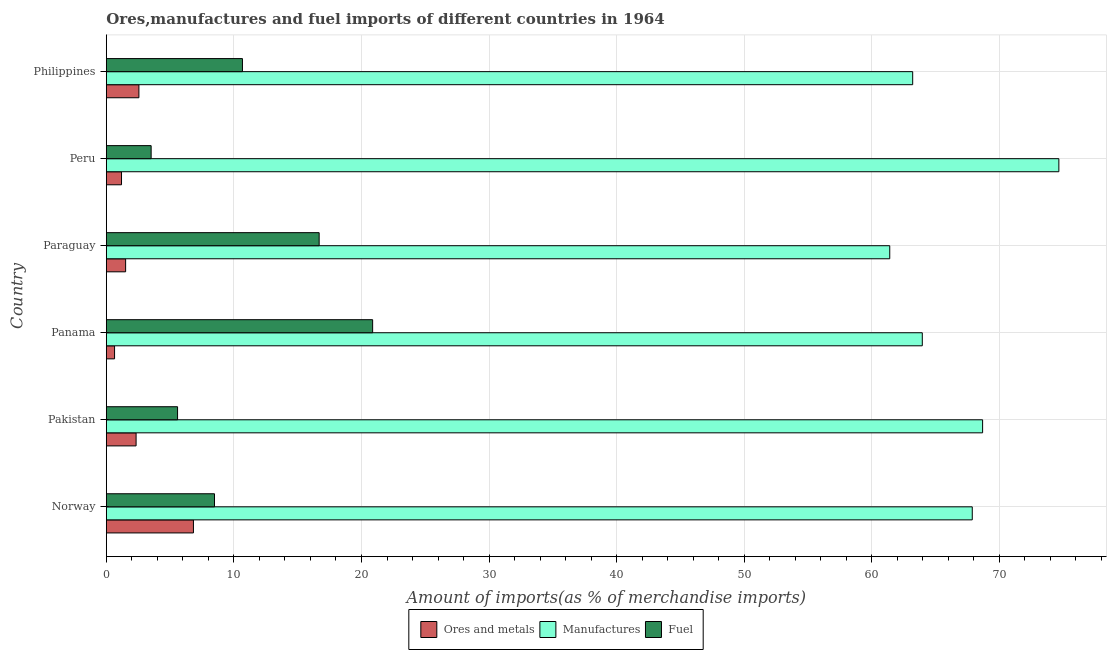How many different coloured bars are there?
Offer a terse response. 3. How many groups of bars are there?
Give a very brief answer. 6. Are the number of bars per tick equal to the number of legend labels?
Offer a terse response. Yes. What is the label of the 2nd group of bars from the top?
Offer a terse response. Peru. In how many cases, is the number of bars for a given country not equal to the number of legend labels?
Keep it short and to the point. 0. What is the percentage of ores and metals imports in Panama?
Your answer should be compact. 0.65. Across all countries, what is the maximum percentage of fuel imports?
Your response must be concise. 20.87. Across all countries, what is the minimum percentage of fuel imports?
Provide a short and direct response. 3.51. In which country was the percentage of manufactures imports minimum?
Ensure brevity in your answer.  Paraguay. What is the total percentage of ores and metals imports in the graph?
Provide a short and direct response. 15.06. What is the difference between the percentage of manufactures imports in Norway and that in Pakistan?
Offer a very short reply. -0.81. What is the difference between the percentage of manufactures imports in Paraguay and the percentage of ores and metals imports in Peru?
Keep it short and to the point. 60.21. What is the average percentage of ores and metals imports per country?
Your answer should be very brief. 2.51. What is the difference between the percentage of fuel imports and percentage of manufactures imports in Peru?
Provide a succinct answer. -71.15. What is the ratio of the percentage of manufactures imports in Norway to that in Philippines?
Give a very brief answer. 1.07. Is the percentage of manufactures imports in Panama less than that in Peru?
Provide a succinct answer. Yes. Is the difference between the percentage of ores and metals imports in Paraguay and Peru greater than the difference between the percentage of manufactures imports in Paraguay and Peru?
Provide a succinct answer. Yes. What is the difference between the highest and the second highest percentage of manufactures imports?
Ensure brevity in your answer.  5.98. What is the difference between the highest and the lowest percentage of fuel imports?
Provide a succinct answer. 17.36. Is the sum of the percentage of manufactures imports in Norway and Peru greater than the maximum percentage of fuel imports across all countries?
Offer a very short reply. Yes. What does the 3rd bar from the top in Philippines represents?
Your answer should be compact. Ores and metals. What does the 3rd bar from the bottom in Philippines represents?
Keep it short and to the point. Fuel. How many bars are there?
Your answer should be compact. 18. Are all the bars in the graph horizontal?
Provide a short and direct response. Yes. What is the difference between two consecutive major ticks on the X-axis?
Keep it short and to the point. 10. Are the values on the major ticks of X-axis written in scientific E-notation?
Provide a succinct answer. No. Does the graph contain grids?
Make the answer very short. Yes. Where does the legend appear in the graph?
Give a very brief answer. Bottom center. How are the legend labels stacked?
Provide a succinct answer. Horizontal. What is the title of the graph?
Keep it short and to the point. Ores,manufactures and fuel imports of different countries in 1964. What is the label or title of the X-axis?
Ensure brevity in your answer.  Amount of imports(as % of merchandise imports). What is the Amount of imports(as % of merchandise imports) of Ores and metals in Norway?
Ensure brevity in your answer.  6.83. What is the Amount of imports(as % of merchandise imports) of Manufactures in Norway?
Offer a very short reply. 67.87. What is the Amount of imports(as % of merchandise imports) in Fuel in Norway?
Offer a very short reply. 8.48. What is the Amount of imports(as % of merchandise imports) in Ores and metals in Pakistan?
Keep it short and to the point. 2.33. What is the Amount of imports(as % of merchandise imports) of Manufactures in Pakistan?
Provide a succinct answer. 68.68. What is the Amount of imports(as % of merchandise imports) in Fuel in Pakistan?
Your response must be concise. 5.58. What is the Amount of imports(as % of merchandise imports) in Ores and metals in Panama?
Your answer should be very brief. 0.65. What is the Amount of imports(as % of merchandise imports) of Manufactures in Panama?
Your response must be concise. 63.96. What is the Amount of imports(as % of merchandise imports) in Fuel in Panama?
Your answer should be very brief. 20.87. What is the Amount of imports(as % of merchandise imports) in Ores and metals in Paraguay?
Your answer should be compact. 1.51. What is the Amount of imports(as % of merchandise imports) of Manufactures in Paraguay?
Your answer should be very brief. 61.4. What is the Amount of imports(as % of merchandise imports) of Fuel in Paraguay?
Provide a succinct answer. 16.68. What is the Amount of imports(as % of merchandise imports) in Ores and metals in Peru?
Give a very brief answer. 1.19. What is the Amount of imports(as % of merchandise imports) of Manufactures in Peru?
Ensure brevity in your answer.  74.66. What is the Amount of imports(as % of merchandise imports) in Fuel in Peru?
Keep it short and to the point. 3.51. What is the Amount of imports(as % of merchandise imports) of Ores and metals in Philippines?
Ensure brevity in your answer.  2.55. What is the Amount of imports(as % of merchandise imports) in Manufactures in Philippines?
Your answer should be compact. 63.2. What is the Amount of imports(as % of merchandise imports) in Fuel in Philippines?
Keep it short and to the point. 10.67. Across all countries, what is the maximum Amount of imports(as % of merchandise imports) in Ores and metals?
Your answer should be compact. 6.83. Across all countries, what is the maximum Amount of imports(as % of merchandise imports) of Manufactures?
Provide a short and direct response. 74.66. Across all countries, what is the maximum Amount of imports(as % of merchandise imports) in Fuel?
Provide a short and direct response. 20.87. Across all countries, what is the minimum Amount of imports(as % of merchandise imports) in Ores and metals?
Your answer should be very brief. 0.65. Across all countries, what is the minimum Amount of imports(as % of merchandise imports) of Manufactures?
Keep it short and to the point. 61.4. Across all countries, what is the minimum Amount of imports(as % of merchandise imports) in Fuel?
Provide a succinct answer. 3.51. What is the total Amount of imports(as % of merchandise imports) in Ores and metals in the graph?
Give a very brief answer. 15.06. What is the total Amount of imports(as % of merchandise imports) in Manufactures in the graph?
Ensure brevity in your answer.  399.78. What is the total Amount of imports(as % of merchandise imports) of Fuel in the graph?
Keep it short and to the point. 65.8. What is the difference between the Amount of imports(as % of merchandise imports) of Ores and metals in Norway and that in Pakistan?
Your response must be concise. 4.5. What is the difference between the Amount of imports(as % of merchandise imports) in Manufactures in Norway and that in Pakistan?
Give a very brief answer. -0.81. What is the difference between the Amount of imports(as % of merchandise imports) in Fuel in Norway and that in Pakistan?
Your answer should be compact. 2.89. What is the difference between the Amount of imports(as % of merchandise imports) in Ores and metals in Norway and that in Panama?
Your answer should be very brief. 6.18. What is the difference between the Amount of imports(as % of merchandise imports) of Manufactures in Norway and that in Panama?
Your answer should be very brief. 3.92. What is the difference between the Amount of imports(as % of merchandise imports) of Fuel in Norway and that in Panama?
Provide a succinct answer. -12.4. What is the difference between the Amount of imports(as % of merchandise imports) of Ores and metals in Norway and that in Paraguay?
Provide a short and direct response. 5.32. What is the difference between the Amount of imports(as % of merchandise imports) of Manufactures in Norway and that in Paraguay?
Make the answer very short. 6.47. What is the difference between the Amount of imports(as % of merchandise imports) of Fuel in Norway and that in Paraguay?
Keep it short and to the point. -8.2. What is the difference between the Amount of imports(as % of merchandise imports) in Ores and metals in Norway and that in Peru?
Provide a short and direct response. 5.64. What is the difference between the Amount of imports(as % of merchandise imports) in Manufactures in Norway and that in Peru?
Give a very brief answer. -6.79. What is the difference between the Amount of imports(as % of merchandise imports) in Fuel in Norway and that in Peru?
Provide a succinct answer. 4.97. What is the difference between the Amount of imports(as % of merchandise imports) of Ores and metals in Norway and that in Philippines?
Provide a short and direct response. 4.27. What is the difference between the Amount of imports(as % of merchandise imports) in Manufactures in Norway and that in Philippines?
Make the answer very short. 4.67. What is the difference between the Amount of imports(as % of merchandise imports) in Fuel in Norway and that in Philippines?
Keep it short and to the point. -2.19. What is the difference between the Amount of imports(as % of merchandise imports) in Ores and metals in Pakistan and that in Panama?
Your answer should be compact. 1.69. What is the difference between the Amount of imports(as % of merchandise imports) in Manufactures in Pakistan and that in Panama?
Make the answer very short. 4.73. What is the difference between the Amount of imports(as % of merchandise imports) in Fuel in Pakistan and that in Panama?
Keep it short and to the point. -15.29. What is the difference between the Amount of imports(as % of merchandise imports) of Ores and metals in Pakistan and that in Paraguay?
Offer a very short reply. 0.82. What is the difference between the Amount of imports(as % of merchandise imports) of Manufactures in Pakistan and that in Paraguay?
Your response must be concise. 7.28. What is the difference between the Amount of imports(as % of merchandise imports) of Fuel in Pakistan and that in Paraguay?
Offer a terse response. -11.1. What is the difference between the Amount of imports(as % of merchandise imports) of Ores and metals in Pakistan and that in Peru?
Give a very brief answer. 1.14. What is the difference between the Amount of imports(as % of merchandise imports) of Manufactures in Pakistan and that in Peru?
Your answer should be very brief. -5.98. What is the difference between the Amount of imports(as % of merchandise imports) in Fuel in Pakistan and that in Peru?
Ensure brevity in your answer.  2.07. What is the difference between the Amount of imports(as % of merchandise imports) in Ores and metals in Pakistan and that in Philippines?
Offer a very short reply. -0.22. What is the difference between the Amount of imports(as % of merchandise imports) of Manufactures in Pakistan and that in Philippines?
Offer a very short reply. 5.48. What is the difference between the Amount of imports(as % of merchandise imports) of Fuel in Pakistan and that in Philippines?
Offer a terse response. -5.09. What is the difference between the Amount of imports(as % of merchandise imports) in Ores and metals in Panama and that in Paraguay?
Offer a very short reply. -0.87. What is the difference between the Amount of imports(as % of merchandise imports) in Manufactures in Panama and that in Paraguay?
Offer a very short reply. 2.55. What is the difference between the Amount of imports(as % of merchandise imports) of Fuel in Panama and that in Paraguay?
Give a very brief answer. 4.19. What is the difference between the Amount of imports(as % of merchandise imports) in Ores and metals in Panama and that in Peru?
Your response must be concise. -0.55. What is the difference between the Amount of imports(as % of merchandise imports) of Manufactures in Panama and that in Peru?
Your answer should be very brief. -10.7. What is the difference between the Amount of imports(as % of merchandise imports) in Fuel in Panama and that in Peru?
Give a very brief answer. 17.36. What is the difference between the Amount of imports(as % of merchandise imports) in Ores and metals in Panama and that in Philippines?
Provide a succinct answer. -1.91. What is the difference between the Amount of imports(as % of merchandise imports) in Manufactures in Panama and that in Philippines?
Ensure brevity in your answer.  0.75. What is the difference between the Amount of imports(as % of merchandise imports) in Fuel in Panama and that in Philippines?
Ensure brevity in your answer.  10.2. What is the difference between the Amount of imports(as % of merchandise imports) of Ores and metals in Paraguay and that in Peru?
Provide a short and direct response. 0.32. What is the difference between the Amount of imports(as % of merchandise imports) of Manufactures in Paraguay and that in Peru?
Offer a terse response. -13.26. What is the difference between the Amount of imports(as % of merchandise imports) of Fuel in Paraguay and that in Peru?
Make the answer very short. 13.17. What is the difference between the Amount of imports(as % of merchandise imports) of Ores and metals in Paraguay and that in Philippines?
Give a very brief answer. -1.04. What is the difference between the Amount of imports(as % of merchandise imports) of Manufactures in Paraguay and that in Philippines?
Your answer should be very brief. -1.8. What is the difference between the Amount of imports(as % of merchandise imports) in Fuel in Paraguay and that in Philippines?
Your answer should be compact. 6.01. What is the difference between the Amount of imports(as % of merchandise imports) in Ores and metals in Peru and that in Philippines?
Make the answer very short. -1.36. What is the difference between the Amount of imports(as % of merchandise imports) of Manufactures in Peru and that in Philippines?
Give a very brief answer. 11.46. What is the difference between the Amount of imports(as % of merchandise imports) in Fuel in Peru and that in Philippines?
Give a very brief answer. -7.16. What is the difference between the Amount of imports(as % of merchandise imports) in Ores and metals in Norway and the Amount of imports(as % of merchandise imports) in Manufactures in Pakistan?
Keep it short and to the point. -61.86. What is the difference between the Amount of imports(as % of merchandise imports) in Ores and metals in Norway and the Amount of imports(as % of merchandise imports) in Fuel in Pakistan?
Offer a terse response. 1.24. What is the difference between the Amount of imports(as % of merchandise imports) of Manufactures in Norway and the Amount of imports(as % of merchandise imports) of Fuel in Pakistan?
Offer a terse response. 62.29. What is the difference between the Amount of imports(as % of merchandise imports) of Ores and metals in Norway and the Amount of imports(as % of merchandise imports) of Manufactures in Panama?
Provide a succinct answer. -57.13. What is the difference between the Amount of imports(as % of merchandise imports) of Ores and metals in Norway and the Amount of imports(as % of merchandise imports) of Fuel in Panama?
Give a very brief answer. -14.05. What is the difference between the Amount of imports(as % of merchandise imports) of Manufactures in Norway and the Amount of imports(as % of merchandise imports) of Fuel in Panama?
Make the answer very short. 47. What is the difference between the Amount of imports(as % of merchandise imports) in Ores and metals in Norway and the Amount of imports(as % of merchandise imports) in Manufactures in Paraguay?
Keep it short and to the point. -54.58. What is the difference between the Amount of imports(as % of merchandise imports) in Ores and metals in Norway and the Amount of imports(as % of merchandise imports) in Fuel in Paraguay?
Keep it short and to the point. -9.85. What is the difference between the Amount of imports(as % of merchandise imports) of Manufactures in Norway and the Amount of imports(as % of merchandise imports) of Fuel in Paraguay?
Offer a very short reply. 51.19. What is the difference between the Amount of imports(as % of merchandise imports) of Ores and metals in Norway and the Amount of imports(as % of merchandise imports) of Manufactures in Peru?
Provide a short and direct response. -67.83. What is the difference between the Amount of imports(as % of merchandise imports) of Ores and metals in Norway and the Amount of imports(as % of merchandise imports) of Fuel in Peru?
Offer a terse response. 3.32. What is the difference between the Amount of imports(as % of merchandise imports) of Manufactures in Norway and the Amount of imports(as % of merchandise imports) of Fuel in Peru?
Your answer should be very brief. 64.36. What is the difference between the Amount of imports(as % of merchandise imports) in Ores and metals in Norway and the Amount of imports(as % of merchandise imports) in Manufactures in Philippines?
Your answer should be very brief. -56.37. What is the difference between the Amount of imports(as % of merchandise imports) of Ores and metals in Norway and the Amount of imports(as % of merchandise imports) of Fuel in Philippines?
Your response must be concise. -3.84. What is the difference between the Amount of imports(as % of merchandise imports) in Manufactures in Norway and the Amount of imports(as % of merchandise imports) in Fuel in Philippines?
Offer a terse response. 57.2. What is the difference between the Amount of imports(as % of merchandise imports) of Ores and metals in Pakistan and the Amount of imports(as % of merchandise imports) of Manufactures in Panama?
Offer a terse response. -61.62. What is the difference between the Amount of imports(as % of merchandise imports) in Ores and metals in Pakistan and the Amount of imports(as % of merchandise imports) in Fuel in Panama?
Ensure brevity in your answer.  -18.54. What is the difference between the Amount of imports(as % of merchandise imports) in Manufactures in Pakistan and the Amount of imports(as % of merchandise imports) in Fuel in Panama?
Your response must be concise. 47.81. What is the difference between the Amount of imports(as % of merchandise imports) of Ores and metals in Pakistan and the Amount of imports(as % of merchandise imports) of Manufactures in Paraguay?
Make the answer very short. -59.07. What is the difference between the Amount of imports(as % of merchandise imports) in Ores and metals in Pakistan and the Amount of imports(as % of merchandise imports) in Fuel in Paraguay?
Make the answer very short. -14.35. What is the difference between the Amount of imports(as % of merchandise imports) in Manufactures in Pakistan and the Amount of imports(as % of merchandise imports) in Fuel in Paraguay?
Provide a short and direct response. 52. What is the difference between the Amount of imports(as % of merchandise imports) of Ores and metals in Pakistan and the Amount of imports(as % of merchandise imports) of Manufactures in Peru?
Offer a very short reply. -72.33. What is the difference between the Amount of imports(as % of merchandise imports) in Ores and metals in Pakistan and the Amount of imports(as % of merchandise imports) in Fuel in Peru?
Your answer should be compact. -1.18. What is the difference between the Amount of imports(as % of merchandise imports) in Manufactures in Pakistan and the Amount of imports(as % of merchandise imports) in Fuel in Peru?
Your answer should be very brief. 65.17. What is the difference between the Amount of imports(as % of merchandise imports) of Ores and metals in Pakistan and the Amount of imports(as % of merchandise imports) of Manufactures in Philippines?
Your answer should be compact. -60.87. What is the difference between the Amount of imports(as % of merchandise imports) of Ores and metals in Pakistan and the Amount of imports(as % of merchandise imports) of Fuel in Philippines?
Give a very brief answer. -8.34. What is the difference between the Amount of imports(as % of merchandise imports) of Manufactures in Pakistan and the Amount of imports(as % of merchandise imports) of Fuel in Philippines?
Your answer should be compact. 58.01. What is the difference between the Amount of imports(as % of merchandise imports) in Ores and metals in Panama and the Amount of imports(as % of merchandise imports) in Manufactures in Paraguay?
Provide a succinct answer. -60.76. What is the difference between the Amount of imports(as % of merchandise imports) in Ores and metals in Panama and the Amount of imports(as % of merchandise imports) in Fuel in Paraguay?
Provide a succinct answer. -16.04. What is the difference between the Amount of imports(as % of merchandise imports) of Manufactures in Panama and the Amount of imports(as % of merchandise imports) of Fuel in Paraguay?
Your response must be concise. 47.27. What is the difference between the Amount of imports(as % of merchandise imports) in Ores and metals in Panama and the Amount of imports(as % of merchandise imports) in Manufactures in Peru?
Offer a very short reply. -74.01. What is the difference between the Amount of imports(as % of merchandise imports) in Ores and metals in Panama and the Amount of imports(as % of merchandise imports) in Fuel in Peru?
Keep it short and to the point. -2.87. What is the difference between the Amount of imports(as % of merchandise imports) of Manufactures in Panama and the Amount of imports(as % of merchandise imports) of Fuel in Peru?
Keep it short and to the point. 60.44. What is the difference between the Amount of imports(as % of merchandise imports) in Ores and metals in Panama and the Amount of imports(as % of merchandise imports) in Manufactures in Philippines?
Offer a terse response. -62.56. What is the difference between the Amount of imports(as % of merchandise imports) in Ores and metals in Panama and the Amount of imports(as % of merchandise imports) in Fuel in Philippines?
Provide a short and direct response. -10.02. What is the difference between the Amount of imports(as % of merchandise imports) in Manufactures in Panama and the Amount of imports(as % of merchandise imports) in Fuel in Philippines?
Offer a very short reply. 53.29. What is the difference between the Amount of imports(as % of merchandise imports) in Ores and metals in Paraguay and the Amount of imports(as % of merchandise imports) in Manufactures in Peru?
Give a very brief answer. -73.15. What is the difference between the Amount of imports(as % of merchandise imports) of Ores and metals in Paraguay and the Amount of imports(as % of merchandise imports) of Fuel in Peru?
Your response must be concise. -2. What is the difference between the Amount of imports(as % of merchandise imports) of Manufactures in Paraguay and the Amount of imports(as % of merchandise imports) of Fuel in Peru?
Your answer should be very brief. 57.89. What is the difference between the Amount of imports(as % of merchandise imports) of Ores and metals in Paraguay and the Amount of imports(as % of merchandise imports) of Manufactures in Philippines?
Give a very brief answer. -61.69. What is the difference between the Amount of imports(as % of merchandise imports) in Ores and metals in Paraguay and the Amount of imports(as % of merchandise imports) in Fuel in Philippines?
Give a very brief answer. -9.16. What is the difference between the Amount of imports(as % of merchandise imports) of Manufactures in Paraguay and the Amount of imports(as % of merchandise imports) of Fuel in Philippines?
Your response must be concise. 50.74. What is the difference between the Amount of imports(as % of merchandise imports) in Ores and metals in Peru and the Amount of imports(as % of merchandise imports) in Manufactures in Philippines?
Ensure brevity in your answer.  -62.01. What is the difference between the Amount of imports(as % of merchandise imports) of Ores and metals in Peru and the Amount of imports(as % of merchandise imports) of Fuel in Philippines?
Give a very brief answer. -9.48. What is the difference between the Amount of imports(as % of merchandise imports) of Manufactures in Peru and the Amount of imports(as % of merchandise imports) of Fuel in Philippines?
Offer a terse response. 63.99. What is the average Amount of imports(as % of merchandise imports) of Ores and metals per country?
Your answer should be compact. 2.51. What is the average Amount of imports(as % of merchandise imports) in Manufactures per country?
Your answer should be compact. 66.63. What is the average Amount of imports(as % of merchandise imports) of Fuel per country?
Provide a short and direct response. 10.97. What is the difference between the Amount of imports(as % of merchandise imports) of Ores and metals and Amount of imports(as % of merchandise imports) of Manufactures in Norway?
Your answer should be compact. -61.04. What is the difference between the Amount of imports(as % of merchandise imports) in Ores and metals and Amount of imports(as % of merchandise imports) in Fuel in Norway?
Ensure brevity in your answer.  -1.65. What is the difference between the Amount of imports(as % of merchandise imports) in Manufactures and Amount of imports(as % of merchandise imports) in Fuel in Norway?
Your response must be concise. 59.39. What is the difference between the Amount of imports(as % of merchandise imports) in Ores and metals and Amount of imports(as % of merchandise imports) in Manufactures in Pakistan?
Ensure brevity in your answer.  -66.35. What is the difference between the Amount of imports(as % of merchandise imports) of Ores and metals and Amount of imports(as % of merchandise imports) of Fuel in Pakistan?
Offer a terse response. -3.25. What is the difference between the Amount of imports(as % of merchandise imports) of Manufactures and Amount of imports(as % of merchandise imports) of Fuel in Pakistan?
Your response must be concise. 63.1. What is the difference between the Amount of imports(as % of merchandise imports) of Ores and metals and Amount of imports(as % of merchandise imports) of Manufactures in Panama?
Give a very brief answer. -63.31. What is the difference between the Amount of imports(as % of merchandise imports) of Ores and metals and Amount of imports(as % of merchandise imports) of Fuel in Panama?
Offer a terse response. -20.23. What is the difference between the Amount of imports(as % of merchandise imports) of Manufactures and Amount of imports(as % of merchandise imports) of Fuel in Panama?
Your answer should be compact. 43.08. What is the difference between the Amount of imports(as % of merchandise imports) of Ores and metals and Amount of imports(as % of merchandise imports) of Manufactures in Paraguay?
Your answer should be very brief. -59.89. What is the difference between the Amount of imports(as % of merchandise imports) of Ores and metals and Amount of imports(as % of merchandise imports) of Fuel in Paraguay?
Make the answer very short. -15.17. What is the difference between the Amount of imports(as % of merchandise imports) in Manufactures and Amount of imports(as % of merchandise imports) in Fuel in Paraguay?
Your answer should be compact. 44.72. What is the difference between the Amount of imports(as % of merchandise imports) in Ores and metals and Amount of imports(as % of merchandise imports) in Manufactures in Peru?
Offer a very short reply. -73.47. What is the difference between the Amount of imports(as % of merchandise imports) in Ores and metals and Amount of imports(as % of merchandise imports) in Fuel in Peru?
Keep it short and to the point. -2.32. What is the difference between the Amount of imports(as % of merchandise imports) in Manufactures and Amount of imports(as % of merchandise imports) in Fuel in Peru?
Offer a terse response. 71.15. What is the difference between the Amount of imports(as % of merchandise imports) in Ores and metals and Amount of imports(as % of merchandise imports) in Manufactures in Philippines?
Provide a succinct answer. -60.65. What is the difference between the Amount of imports(as % of merchandise imports) in Ores and metals and Amount of imports(as % of merchandise imports) in Fuel in Philippines?
Your response must be concise. -8.12. What is the difference between the Amount of imports(as % of merchandise imports) of Manufactures and Amount of imports(as % of merchandise imports) of Fuel in Philippines?
Make the answer very short. 52.53. What is the ratio of the Amount of imports(as % of merchandise imports) in Ores and metals in Norway to that in Pakistan?
Provide a succinct answer. 2.93. What is the ratio of the Amount of imports(as % of merchandise imports) in Fuel in Norway to that in Pakistan?
Provide a short and direct response. 1.52. What is the ratio of the Amount of imports(as % of merchandise imports) in Ores and metals in Norway to that in Panama?
Ensure brevity in your answer.  10.58. What is the ratio of the Amount of imports(as % of merchandise imports) in Manufactures in Norway to that in Panama?
Ensure brevity in your answer.  1.06. What is the ratio of the Amount of imports(as % of merchandise imports) of Fuel in Norway to that in Panama?
Ensure brevity in your answer.  0.41. What is the ratio of the Amount of imports(as % of merchandise imports) in Ores and metals in Norway to that in Paraguay?
Give a very brief answer. 4.51. What is the ratio of the Amount of imports(as % of merchandise imports) in Manufactures in Norway to that in Paraguay?
Keep it short and to the point. 1.11. What is the ratio of the Amount of imports(as % of merchandise imports) in Fuel in Norway to that in Paraguay?
Your answer should be very brief. 0.51. What is the ratio of the Amount of imports(as % of merchandise imports) in Ores and metals in Norway to that in Peru?
Make the answer very short. 5.74. What is the ratio of the Amount of imports(as % of merchandise imports) in Fuel in Norway to that in Peru?
Ensure brevity in your answer.  2.41. What is the ratio of the Amount of imports(as % of merchandise imports) in Ores and metals in Norway to that in Philippines?
Your answer should be very brief. 2.67. What is the ratio of the Amount of imports(as % of merchandise imports) in Manufactures in Norway to that in Philippines?
Make the answer very short. 1.07. What is the ratio of the Amount of imports(as % of merchandise imports) of Fuel in Norway to that in Philippines?
Make the answer very short. 0.79. What is the ratio of the Amount of imports(as % of merchandise imports) in Ores and metals in Pakistan to that in Panama?
Your response must be concise. 3.62. What is the ratio of the Amount of imports(as % of merchandise imports) of Manufactures in Pakistan to that in Panama?
Your response must be concise. 1.07. What is the ratio of the Amount of imports(as % of merchandise imports) of Fuel in Pakistan to that in Panama?
Your answer should be very brief. 0.27. What is the ratio of the Amount of imports(as % of merchandise imports) of Ores and metals in Pakistan to that in Paraguay?
Offer a terse response. 1.54. What is the ratio of the Amount of imports(as % of merchandise imports) of Manufactures in Pakistan to that in Paraguay?
Offer a very short reply. 1.12. What is the ratio of the Amount of imports(as % of merchandise imports) in Fuel in Pakistan to that in Paraguay?
Your answer should be very brief. 0.33. What is the ratio of the Amount of imports(as % of merchandise imports) of Ores and metals in Pakistan to that in Peru?
Offer a terse response. 1.96. What is the ratio of the Amount of imports(as % of merchandise imports) of Manufactures in Pakistan to that in Peru?
Provide a succinct answer. 0.92. What is the ratio of the Amount of imports(as % of merchandise imports) of Fuel in Pakistan to that in Peru?
Make the answer very short. 1.59. What is the ratio of the Amount of imports(as % of merchandise imports) of Ores and metals in Pakistan to that in Philippines?
Your answer should be very brief. 0.91. What is the ratio of the Amount of imports(as % of merchandise imports) of Manufactures in Pakistan to that in Philippines?
Keep it short and to the point. 1.09. What is the ratio of the Amount of imports(as % of merchandise imports) of Fuel in Pakistan to that in Philippines?
Make the answer very short. 0.52. What is the ratio of the Amount of imports(as % of merchandise imports) of Ores and metals in Panama to that in Paraguay?
Give a very brief answer. 0.43. What is the ratio of the Amount of imports(as % of merchandise imports) in Manufactures in Panama to that in Paraguay?
Offer a very short reply. 1.04. What is the ratio of the Amount of imports(as % of merchandise imports) of Fuel in Panama to that in Paraguay?
Provide a short and direct response. 1.25. What is the ratio of the Amount of imports(as % of merchandise imports) in Ores and metals in Panama to that in Peru?
Your answer should be very brief. 0.54. What is the ratio of the Amount of imports(as % of merchandise imports) in Manufactures in Panama to that in Peru?
Make the answer very short. 0.86. What is the ratio of the Amount of imports(as % of merchandise imports) in Fuel in Panama to that in Peru?
Provide a succinct answer. 5.94. What is the ratio of the Amount of imports(as % of merchandise imports) in Ores and metals in Panama to that in Philippines?
Provide a succinct answer. 0.25. What is the ratio of the Amount of imports(as % of merchandise imports) in Manufactures in Panama to that in Philippines?
Keep it short and to the point. 1.01. What is the ratio of the Amount of imports(as % of merchandise imports) of Fuel in Panama to that in Philippines?
Provide a succinct answer. 1.96. What is the ratio of the Amount of imports(as % of merchandise imports) of Ores and metals in Paraguay to that in Peru?
Your response must be concise. 1.27. What is the ratio of the Amount of imports(as % of merchandise imports) of Manufactures in Paraguay to that in Peru?
Your answer should be very brief. 0.82. What is the ratio of the Amount of imports(as % of merchandise imports) in Fuel in Paraguay to that in Peru?
Your answer should be very brief. 4.75. What is the ratio of the Amount of imports(as % of merchandise imports) of Ores and metals in Paraguay to that in Philippines?
Your answer should be compact. 0.59. What is the ratio of the Amount of imports(as % of merchandise imports) in Manufactures in Paraguay to that in Philippines?
Your answer should be very brief. 0.97. What is the ratio of the Amount of imports(as % of merchandise imports) of Fuel in Paraguay to that in Philippines?
Offer a terse response. 1.56. What is the ratio of the Amount of imports(as % of merchandise imports) in Ores and metals in Peru to that in Philippines?
Make the answer very short. 0.47. What is the ratio of the Amount of imports(as % of merchandise imports) of Manufactures in Peru to that in Philippines?
Keep it short and to the point. 1.18. What is the ratio of the Amount of imports(as % of merchandise imports) of Fuel in Peru to that in Philippines?
Ensure brevity in your answer.  0.33. What is the difference between the highest and the second highest Amount of imports(as % of merchandise imports) of Ores and metals?
Provide a short and direct response. 4.27. What is the difference between the highest and the second highest Amount of imports(as % of merchandise imports) of Manufactures?
Provide a succinct answer. 5.98. What is the difference between the highest and the second highest Amount of imports(as % of merchandise imports) of Fuel?
Ensure brevity in your answer.  4.19. What is the difference between the highest and the lowest Amount of imports(as % of merchandise imports) of Ores and metals?
Give a very brief answer. 6.18. What is the difference between the highest and the lowest Amount of imports(as % of merchandise imports) of Manufactures?
Your answer should be very brief. 13.26. What is the difference between the highest and the lowest Amount of imports(as % of merchandise imports) in Fuel?
Give a very brief answer. 17.36. 